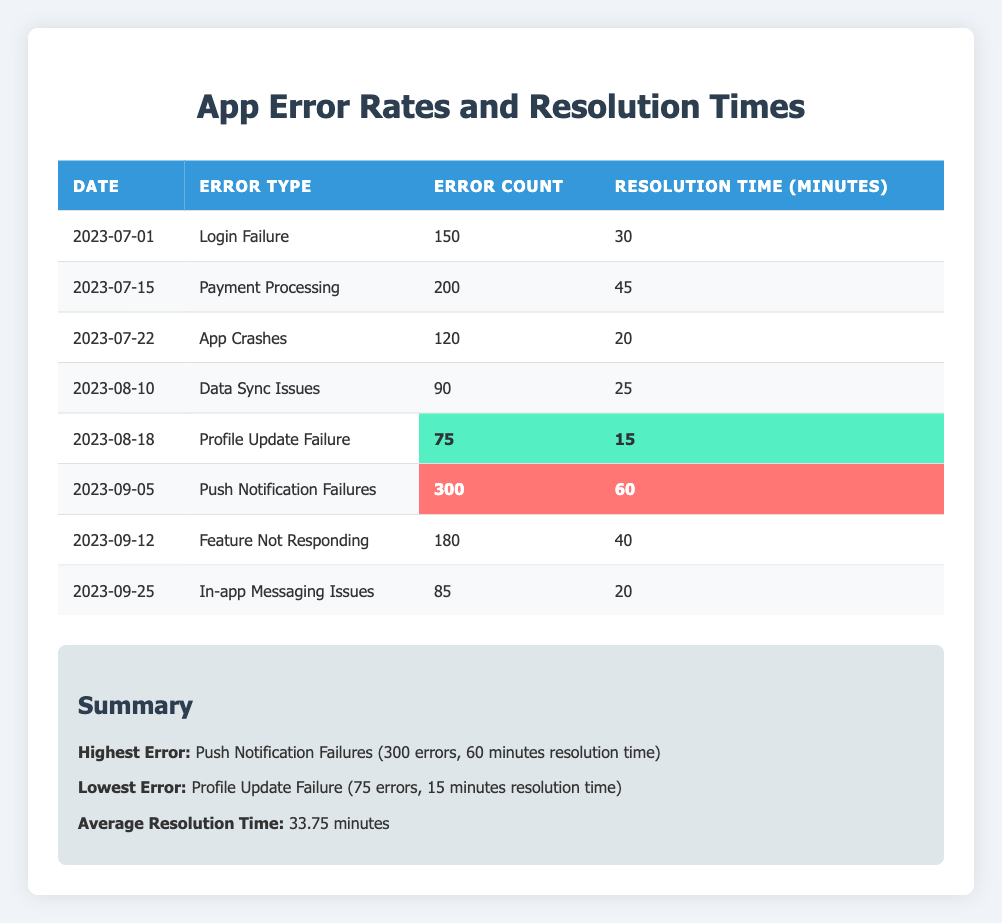What was the highest error count in the last quarter? The highest error count in the table is found next to "Push Notification Failures", which lists 300 errors.
Answer: 300 Which error type had the lowest resolution time? In the table, the "Profile Update Failure" shows the lowest resolution time at 15 minutes.
Answer: 15 minutes How many error types had a resolution time greater than 30 minutes? The error types with resolution times greater than 30 minutes are "Payment Processing" (45 minutes), "Push Notification Failures" (60 minutes), and "Feature Not Responding" (40 minutes). There are three such error types.
Answer: 3 What is the total number of error counts across all error types in the last quarter? Adding the error counts: 150 + 200 + 120 + 90 + 75 + 300 + 180 + 85 equals 1,200. Therefore, the total error count is 1,200.
Answer: 1200 Is the error count for "Data Sync Issues" greater than the average error count for all types? The error count for "Data Sync Issues" is 90, while the average error count is calculated by dividing the total of all error counts (1,200) by the number of error types (8), which results in an average of 150. Since 90 is less than 150, the statement is false.
Answer: No What is the average resolution time for all the error types? The average resolution time is calculated by summing all resolution times (30 + 45 + 20 + 25 + 15 + 60 + 40 + 20 = 305) and dividing by the number of error types (8), resulting in an average of 33.75 minutes.
Answer: 33.75 minutes Which error types had more than 100 errors but less than 300 errors? The error types that fall within this range are "Login Failure" (150 errors), "Payment Processing" (200 errors), and "Feature Not Responding" (180 errors).
Answer: 3 types Was the resolution time for "App Crashes" less than or equal to the average resolution time? The resolution time for "App Crashes" is 20 minutes, and the average resolution time is 33.75 minutes. Since 20 minutes is less than 33.75 minutes, the statement is true.
Answer: Yes How many errors were resolved in total within less than 30 minutes? The error types resolved in less than 30 minutes are "Profile Update Failure" (15 minutes), "App Crashes" (20 minutes), and "In-app Messaging Issues" (20 minutes). This gives a total of 75 + 120 + 85 = 280 errors.
Answer: 280 